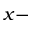<formula> <loc_0><loc_0><loc_500><loc_500>x -</formula> 